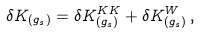Convert formula to latex. <formula><loc_0><loc_0><loc_500><loc_500>\delta K _ { ( g _ { s } ) } = \delta K _ { ( g _ { s } ) } ^ { K K } + \delta K _ { ( g _ { s } ) } ^ { W } \, ,</formula> 